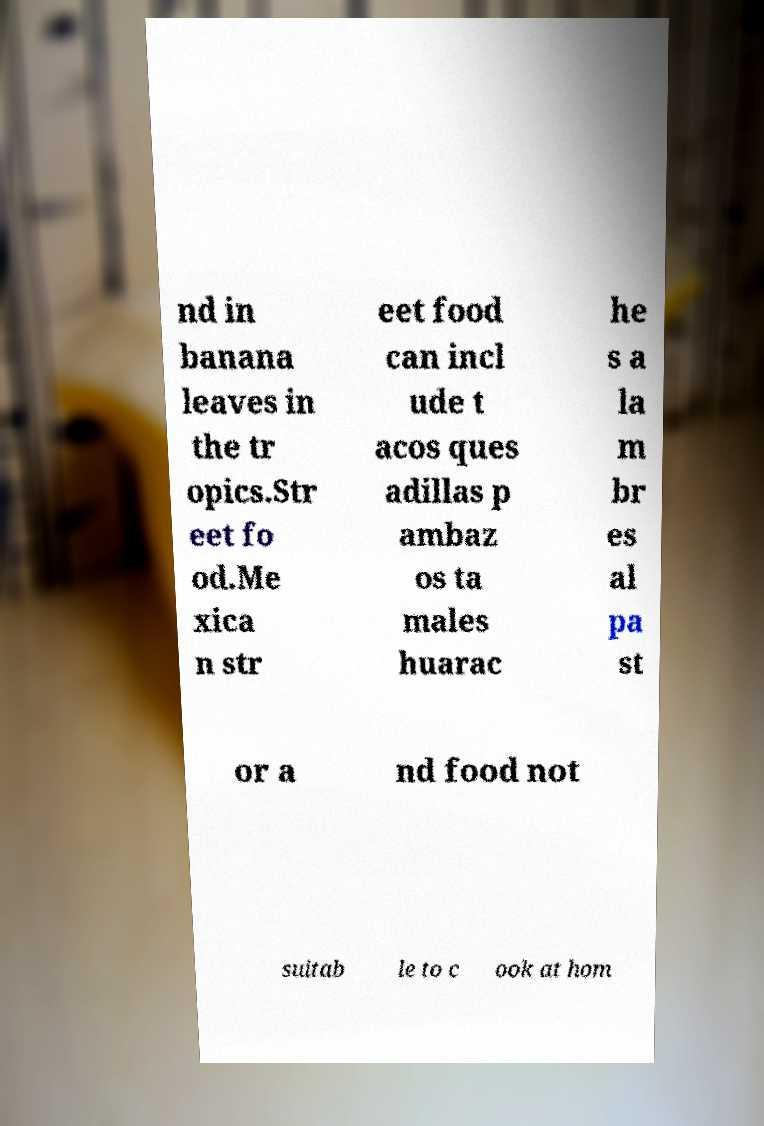Could you assist in decoding the text presented in this image and type it out clearly? nd in banana leaves in the tr opics.Str eet fo od.Me xica n str eet food can incl ude t acos ques adillas p ambaz os ta males huarac he s a la m br es al pa st or a nd food not suitab le to c ook at hom 